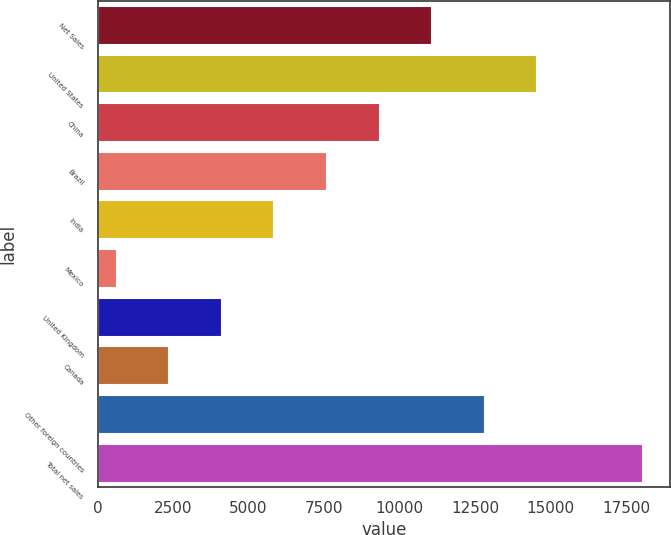<chart> <loc_0><loc_0><loc_500><loc_500><bar_chart><fcel>Net Sales<fcel>United States<fcel>China<fcel>Brazil<fcel>India<fcel>Mexico<fcel>United Kingdom<fcel>Canada<fcel>Other foreign countries<fcel>Total net sales<nl><fcel>11081.2<fcel>14564.6<fcel>9339.5<fcel>7597.8<fcel>5856.1<fcel>631<fcel>4114.4<fcel>2372.7<fcel>12822.9<fcel>18048<nl></chart> 